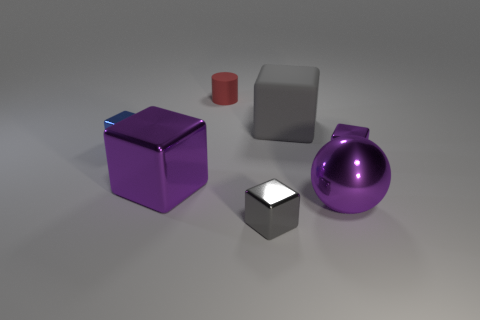Subtract all tiny purple metallic blocks. How many blocks are left? 4 Subtract all gray cubes. How many cubes are left? 3 Subtract 2 cubes. How many cubes are left? 3 Add 3 red rubber objects. How many objects exist? 10 Subtract all green blocks. How many cyan balls are left? 0 Subtract 0 cyan cubes. How many objects are left? 7 Subtract all balls. How many objects are left? 6 Subtract all green spheres. Subtract all yellow cylinders. How many spheres are left? 1 Subtract all tiny purple blocks. Subtract all red things. How many objects are left? 5 Add 6 big shiny cubes. How many big shiny cubes are left? 7 